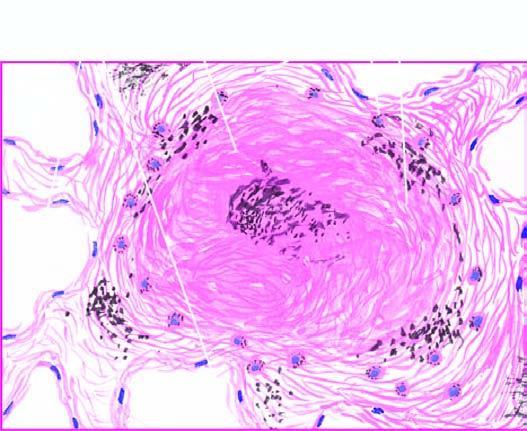does the margin of the colony show bright fibres of silica?
Answer the question using a single word or phrase. No 